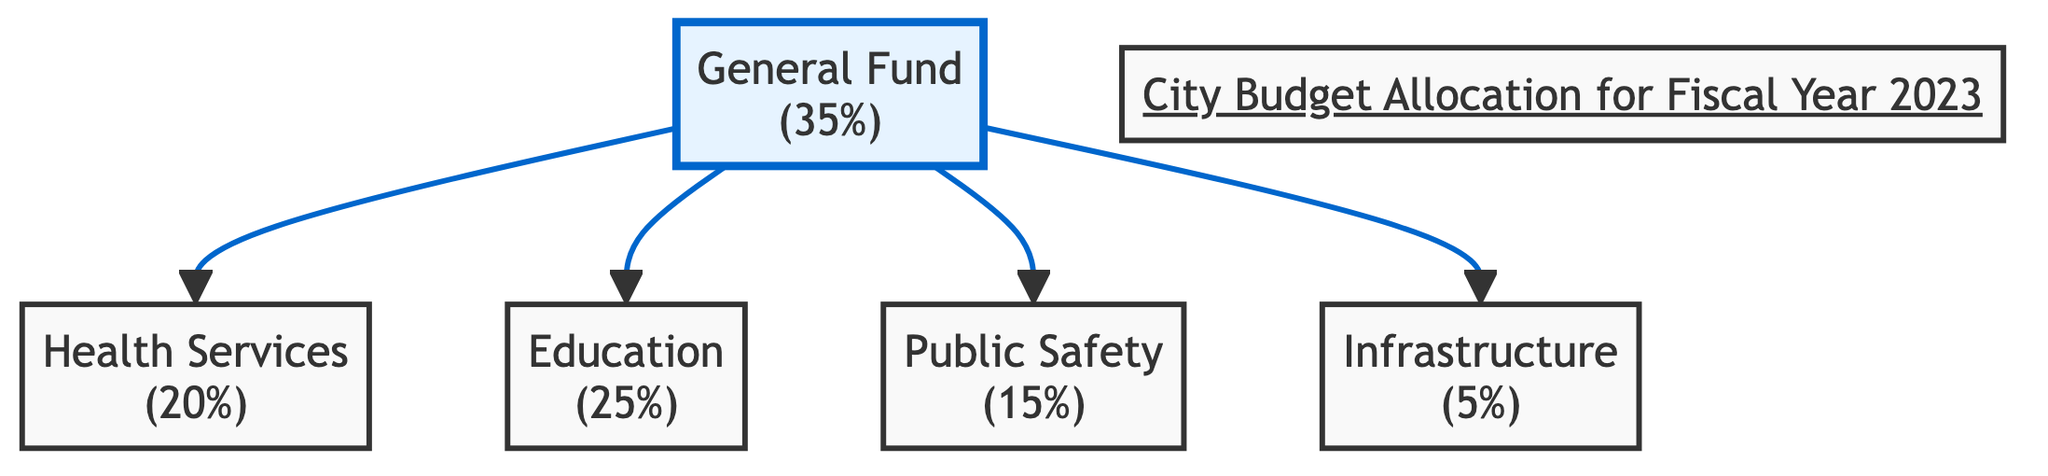What percentage of the budget is allocated to Health Services? The diagram states that Health Services is allocated 20% of the budget. Therefore, we directly refer to the percentage indicated next to the Health Services node.
Answer: 20% How many departments are funded by the General Fund? The diagram shows that the General Fund allocates budget to four departments: Health Services, Education, Public Safety, and Infrastructure. We count the connections (edges) from the General Fund to these departments.
Answer: 4 What is the percentage allocation for Education? The diagram indicates that Education has a budget allocation of 25%. This percentage is clearly labeled next to the Education node.
Answer: 25% Which department has the lowest budget percentage? According to the diagram, Infrastructure has the lowest allocation at 5%. We can identify this by comparing the percentages displayed next to each department.
Answer: Infrastructure What is the combined percentage of the budget for Public Safety and Health Services? To find this combined percentage, we add the allocations: Public Safety (15%) + Health Services (20%) = 35%. We sum the values indicated next to the respective nodes.
Answer: 35% Which department receives a higher budget: Health Services or Public Safety? By comparing the two percentages directly, Health Services receives 20%, while Public Safety receives 15%. Therefore, Health Services has a higher allocation.
Answer: Health Services What percentage of the budget is not allocated to Infrastructure? The allocation to Infrastructure is 5%, so to calculate the remainder not allocated to Infrastructure, we subtract it from 100%: 100% - 5% = 95%. This represents the budget remaining after accounting for Infrastructure.
Answer: 95% What is the total percentage allocated to all departments connected to the General Fund? The total percentage is calculated by summing all allocations: 20% (Health Services) + 25% (Education) + 15% (Public Safety) + 5% (Infrastructure) = 65%. We add these values to find the total distribution across connected departments.
Answer: 65% In this diagram, how many edges connect the General Fund to other departments? The diagram shows four connections (edges) originating from the General Fund to Health Services, Education, Public Safety, and Infrastructure. We count each line leading from the General Fund to these departments.
Answer: 4 